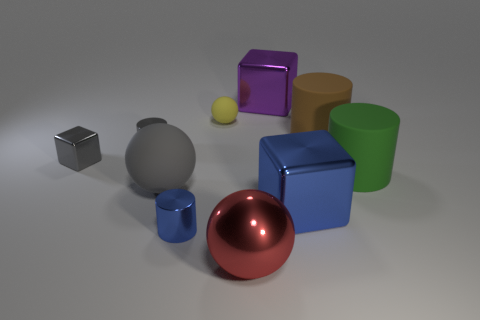Are there any objects with transparency or translucency in this image? No, all objects in this image display solid, opaque surfaces without any transparency or translucency. They fully reflect and diffuse light, obscuring any view through them.  If these objects were part of a children's game, what could be some rules based on their shapes and colors? Players could be tasked with grouping objects by shape or color, creating patterns, or stacking them without toppling. Points could be scored for speed, accuracy, or the complexity of the pattern created. 